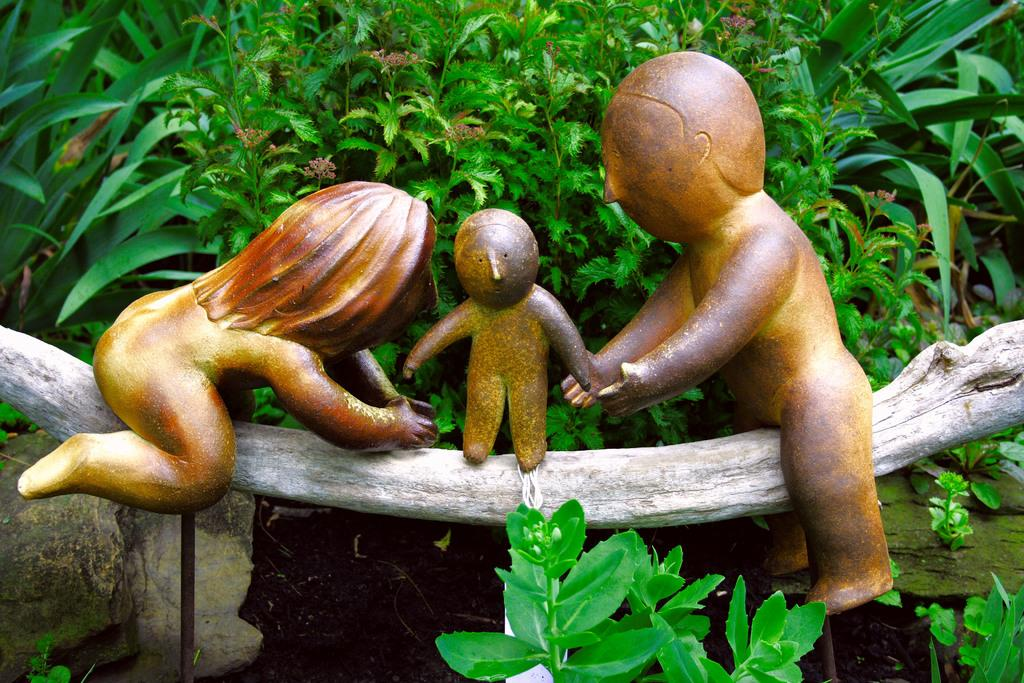What is located in the center of the image? There are toys in the center of the image. Where are the toys placed? The toys are placed on a log. What can be seen in the background of the image? There are plants in the background of the image. What type of amusement can be seen in the image? There is no amusement park or ride present in the image; it features toys placed on a log with plants in the background. What agreement was reached regarding the toys in the image? There is no indication of any agreement or discussion related to the toys in the image. 